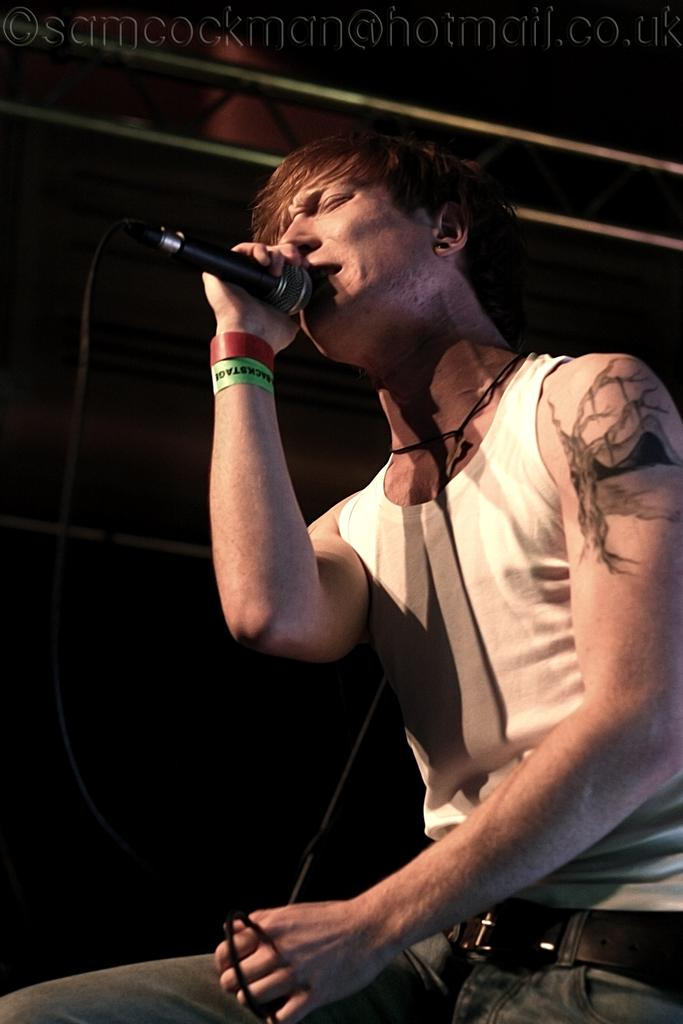Who is the main subject in the image? There is a man in the image. What is the man holding in the image? The man is holding a microphone. What is the man doing with the microphone? The man is singing a song. What type of ornament is hanging from the microphone in the image? There is no ornament hanging from the microphone in the image. 